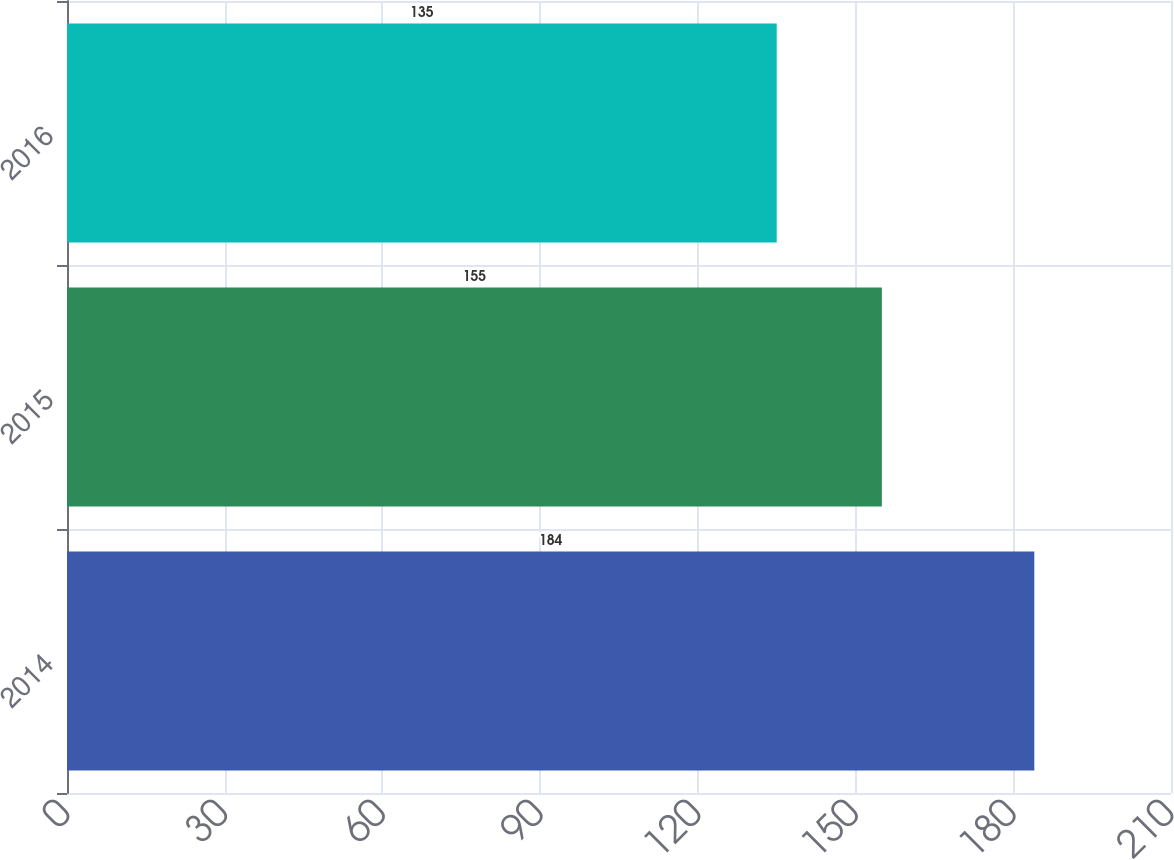Convert chart. <chart><loc_0><loc_0><loc_500><loc_500><bar_chart><fcel>2014<fcel>2015<fcel>2016<nl><fcel>184<fcel>155<fcel>135<nl></chart> 